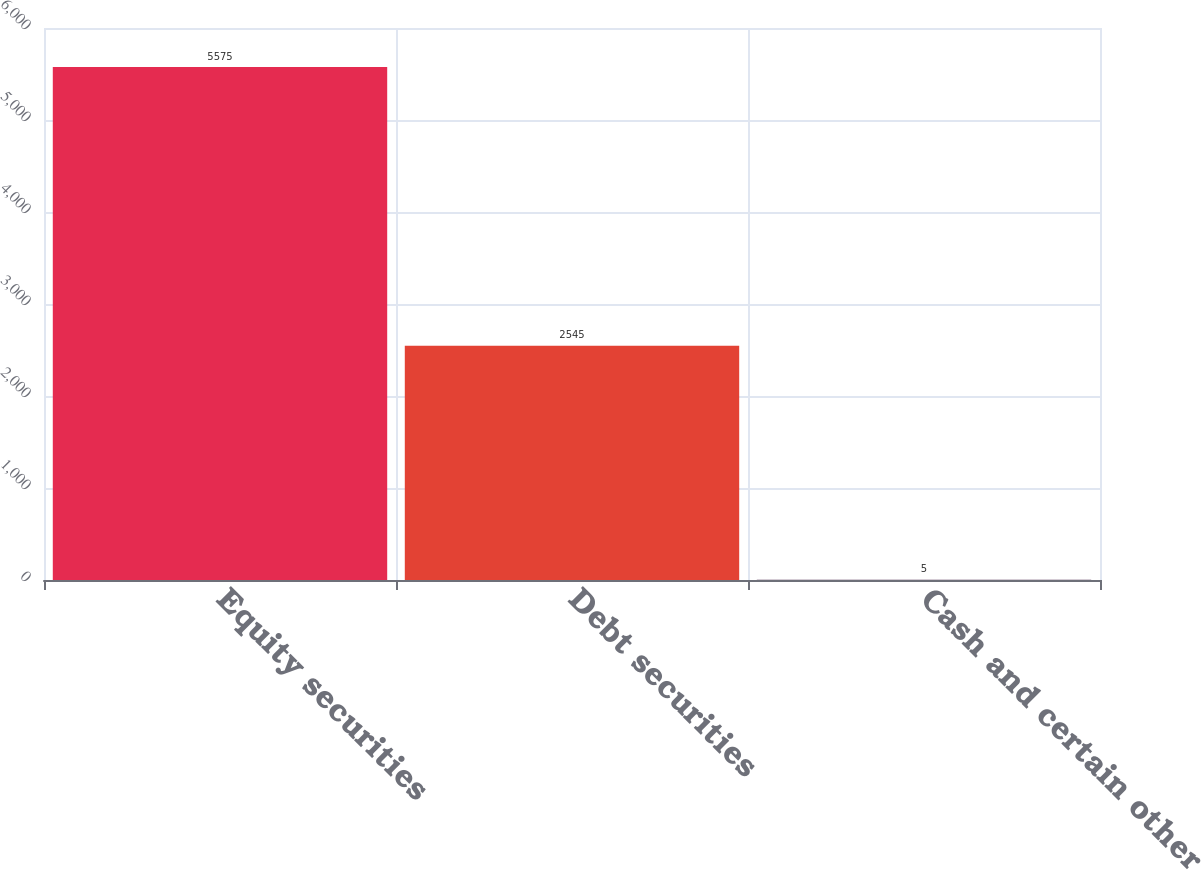<chart> <loc_0><loc_0><loc_500><loc_500><bar_chart><fcel>Equity securities<fcel>Debt securities<fcel>Cash and certain other<nl><fcel>5575<fcel>2545<fcel>5<nl></chart> 